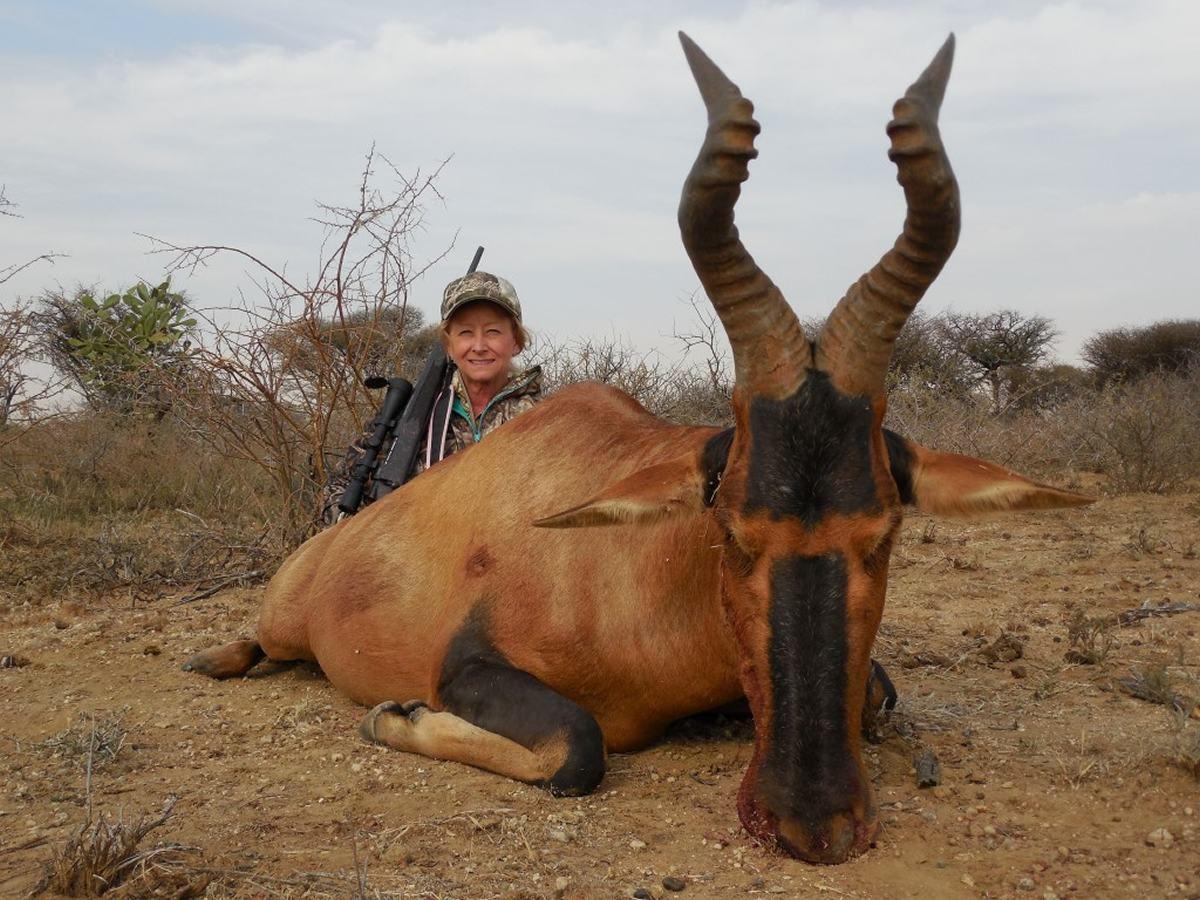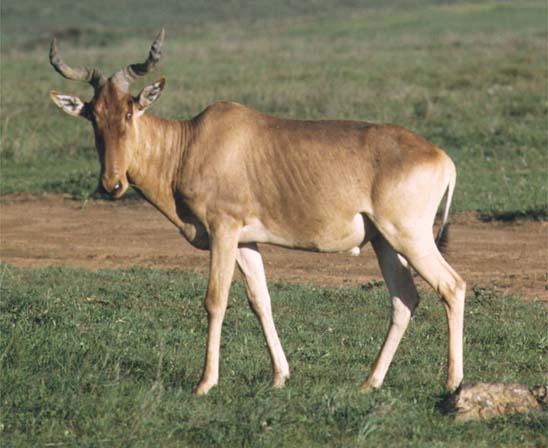The first image is the image on the left, the second image is the image on the right. Given the left and right images, does the statement "The animal in the image on the right is standing in side profile with its head turned toward the camera." hold true? Answer yes or no. Yes. 